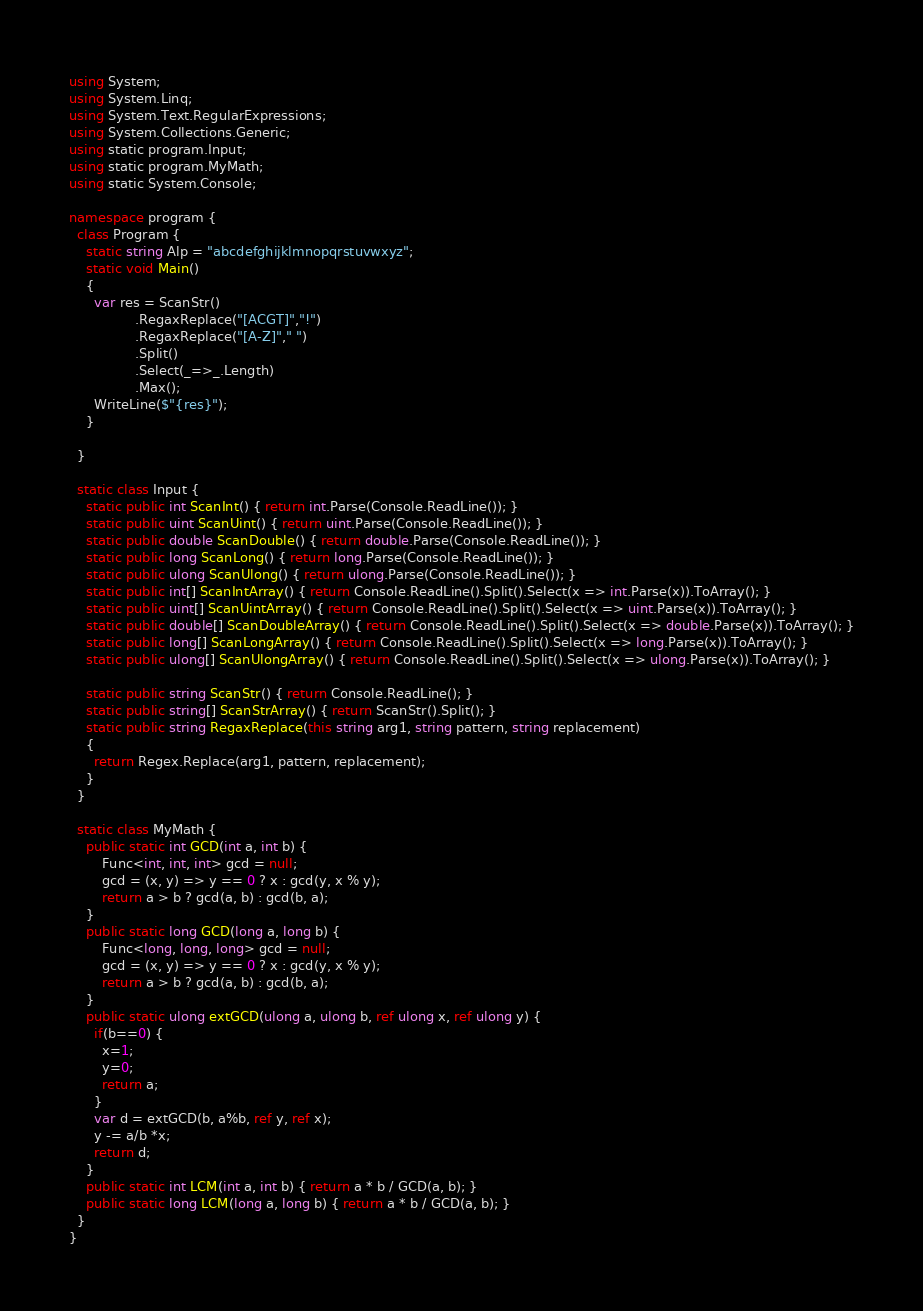Convert code to text. <code><loc_0><loc_0><loc_500><loc_500><_C#_>using System;
using System.Linq;
using System.Text.RegularExpressions;
using System.Collections.Generic;
using static program.Input;
using static program.MyMath;
using static System.Console;

namespace program {
  class Program {
    static string Alp = "abcdefghijklmnopqrstuvwxyz";
    static void Main()
    {
      var res = ScanStr()
        		.RegaxReplace("[ACGT]","!")
        		.RegaxReplace("[A-Z]"," ")
        		.Split()
        		.Select(_=>_.Length)
        		.Max();
      WriteLine($"{res}");
    }
    
  }
  
  static class Input {
    static public int ScanInt() { return int.Parse(Console.ReadLine()); }
    static public uint ScanUint() { return uint.Parse(Console.ReadLine()); }
    static public double ScanDouble() { return double.Parse(Console.ReadLine()); }
    static public long ScanLong() { return long.Parse(Console.ReadLine()); }
    static public ulong ScanUlong() { return ulong.Parse(Console.ReadLine()); }
    static public int[] ScanIntArray() { return Console.ReadLine().Split().Select(x => int.Parse(x)).ToArray(); }
    static public uint[] ScanUintArray() { return Console.ReadLine().Split().Select(x => uint.Parse(x)).ToArray(); }
    static public double[] ScanDoubleArray() { return Console.ReadLine().Split().Select(x => double.Parse(x)).ToArray(); }
    static public long[] ScanLongArray() { return Console.ReadLine().Split().Select(x => long.Parse(x)).ToArray(); }
    static public ulong[] ScanUlongArray() { return Console.ReadLine().Split().Select(x => ulong.Parse(x)).ToArray(); }

    static public string ScanStr() { return Console.ReadLine(); }
    static public string[] ScanStrArray() { return ScanStr().Split(); }
    static public string RegaxReplace(this string arg1, string pattern, string replacement)
    {
      return Regex.Replace(arg1, pattern, replacement);
    }
  }
  
  static class MyMath {
    public static int GCD(int a, int b) {
        Func<int, int, int> gcd = null;
        gcd = (x, y) => y == 0 ? x : gcd(y, x % y);
        return a > b ? gcd(a, b) : gcd(b, a);
    }
    public static long GCD(long a, long b) {
        Func<long, long, long> gcd = null;
        gcd = (x, y) => y == 0 ? x : gcd(y, x % y);
        return a > b ? gcd(a, b) : gcd(b, a);
    }
    public static ulong extGCD(ulong a, ulong b, ref ulong x, ref ulong y) {
      if(b==0) {
        x=1; 
        y=0;
        return a;
      }
      var d = extGCD(b, a%b, ref y, ref x);
      y -= a/b *x;
      return d;
    }
    public static int LCM(int a, int b) { return a * b / GCD(a, b); }
    public static long LCM(long a, long b) { return a * b / GCD(a, b); }
  }
}
</code> 